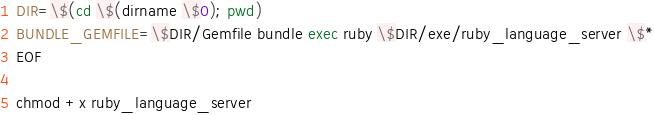<code> <loc_0><loc_0><loc_500><loc_500><_Bash_>DIR=\$(cd \$(dirname \$0); pwd)
BUNDLE_GEMFILE=\$DIR/Gemfile bundle exec ruby \$DIR/exe/ruby_language_server \$*
EOF

chmod +x ruby_language_server
</code> 